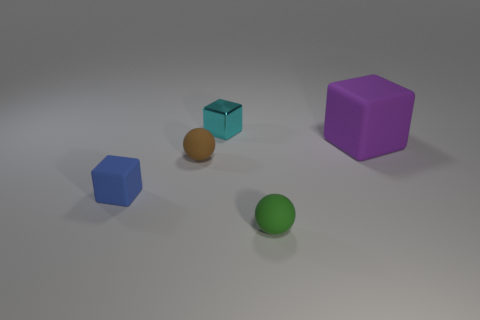Add 3 big gray matte objects. How many objects exist? 8 Subtract all cubes. How many objects are left? 2 Add 2 small objects. How many small objects exist? 6 Subtract 1 blue cubes. How many objects are left? 4 Subtract all small green rubber spheres. Subtract all big objects. How many objects are left? 3 Add 3 blue matte blocks. How many blue matte blocks are left? 4 